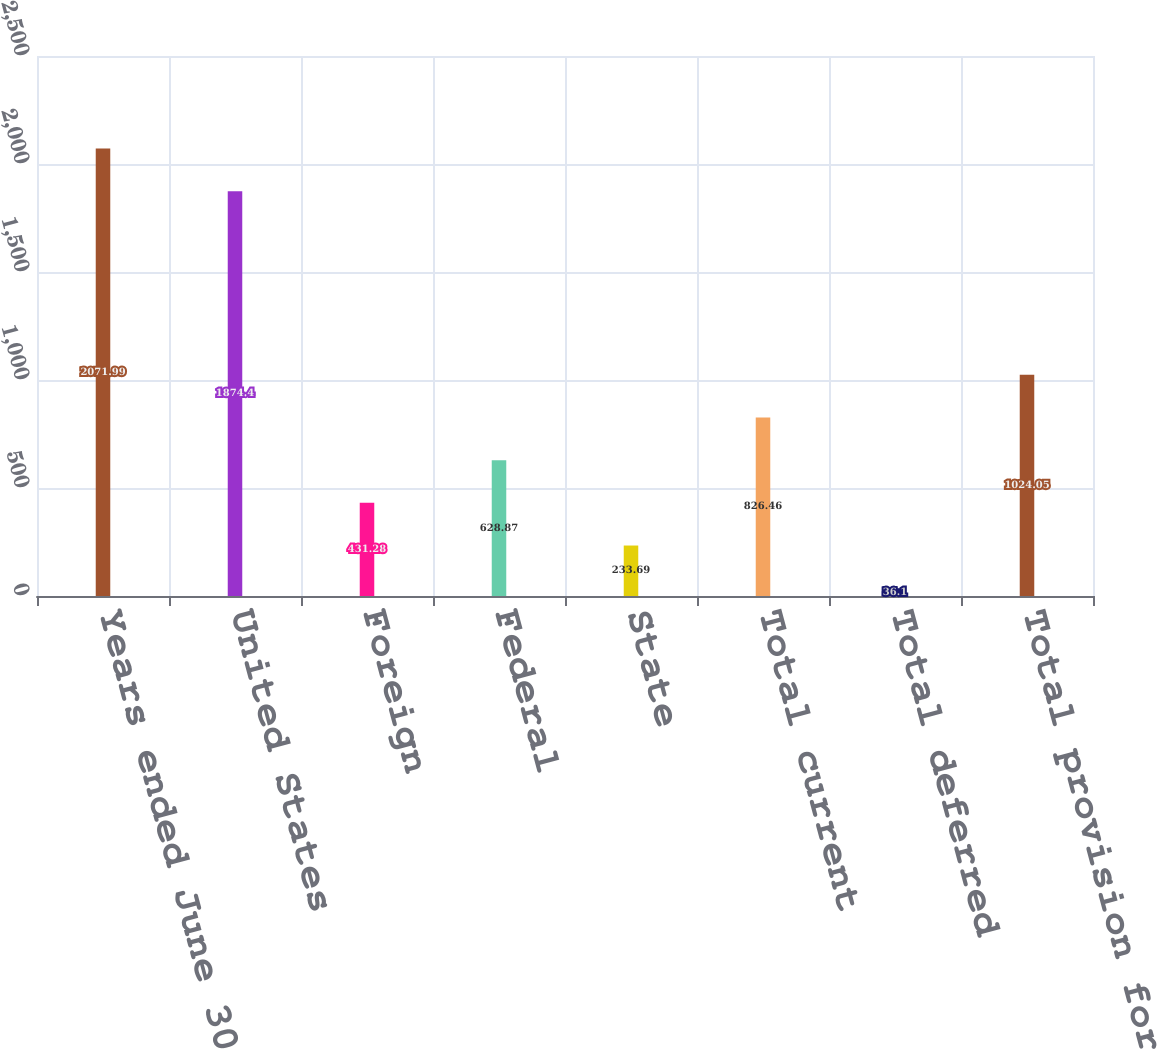Convert chart to OTSL. <chart><loc_0><loc_0><loc_500><loc_500><bar_chart><fcel>Years ended June 30<fcel>United States<fcel>Foreign<fcel>Federal<fcel>State<fcel>Total current<fcel>Total deferred<fcel>Total provision for income<nl><fcel>2071.99<fcel>1874.4<fcel>431.28<fcel>628.87<fcel>233.69<fcel>826.46<fcel>36.1<fcel>1024.05<nl></chart> 